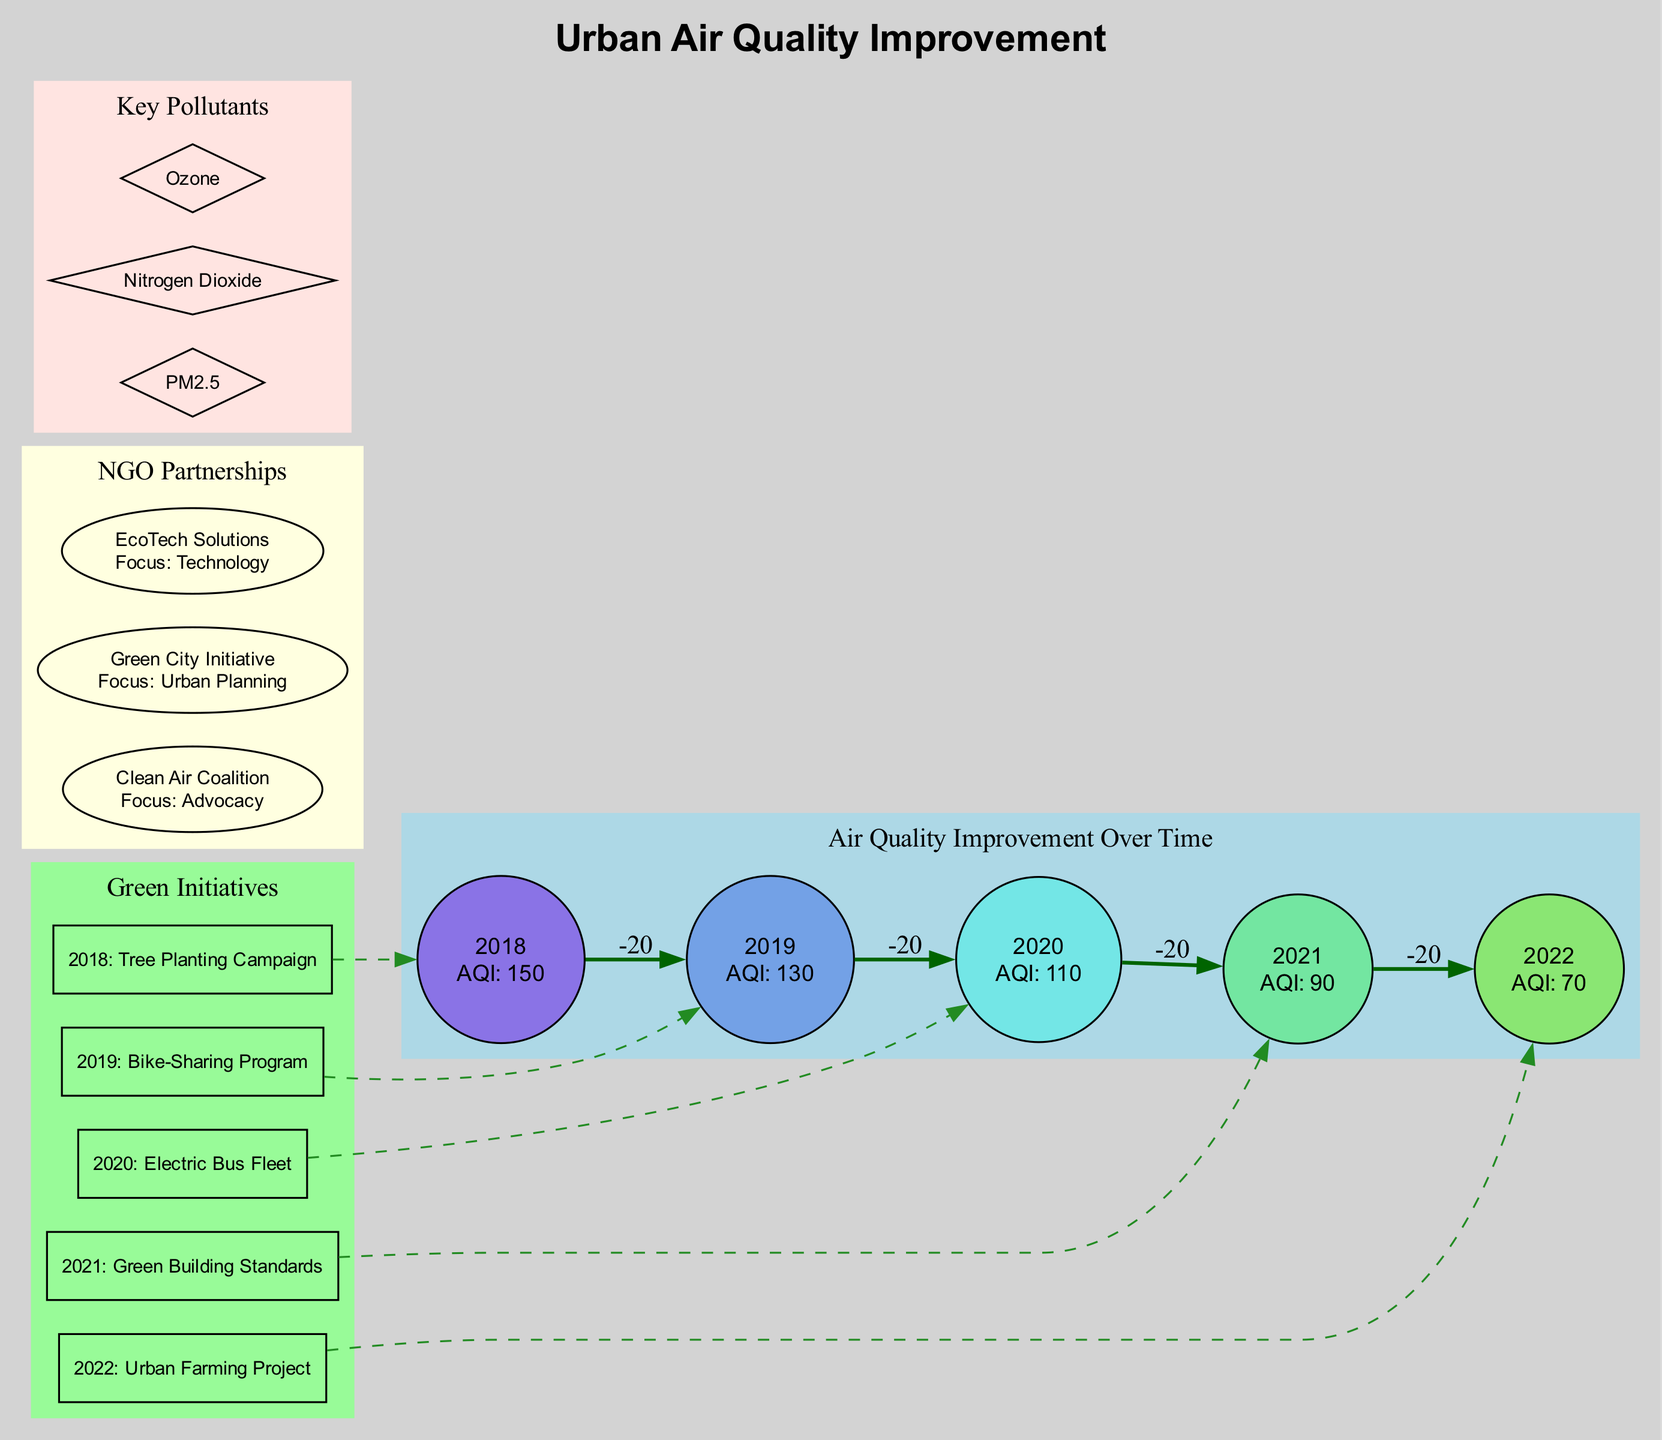What was the Air Quality Index (AQI) in 2020? The diagram shows the AQI for each year. For 2020, the AQI value is explicitly stated as 110.
Answer: 110 Which green initiative was implemented in 2019? The diagram lists corresponding green initiatives alongside their years. In 2019, the initiative is identified as the Bike-Sharing Program.
Answer: Bike-Sharing Program How many key pollutants are mentioned in the diagram? The key pollutants section of the diagram contains a list. There are three distinct pollutants: PM2.5, Nitrogen Dioxide, and Ozone. Thus, the count is three.
Answer: 3 What is the relationship between the "Electric Bus Fleet" initiative and the AQI for 2020? The diagram links the Electric Bus Fleet initiative to the AQI for 2020. It uses a dashed edge, suggesting that this initiative was a contributing factor towards the reduction in AQI, which was at 110 for that year.
Answer: Contributing factor What was the trend in air quality from 2018 to 2022? By analyzing the AQI values from 2018 (150) to 2022 (70), the data indicates a steady decrease in AQI each year, reflecting an overall trend of air quality improvement.
Answer: Steady decrease Which NGO focuses on urban planning? The NGO partnerships section lists several organizations, and the one focusing on urban planning is identified as Green City Initiative.
Answer: Green City Initiative In which year did the AQI drop below 100 for the first time? The AQI values for the years listed show that the first occurrence below 100 happened in 2021, when the AQI registered at 90.
Answer: 2021 How many green initiatives correspond with a year where the AQI improved? Each year has a corresponding green initiative, and looking at the years listed from 2018 to 2022 shows all had improvements in AQI, indicating that there were five initiatives that corresponded with improved AQI levels.
Answer: 5 